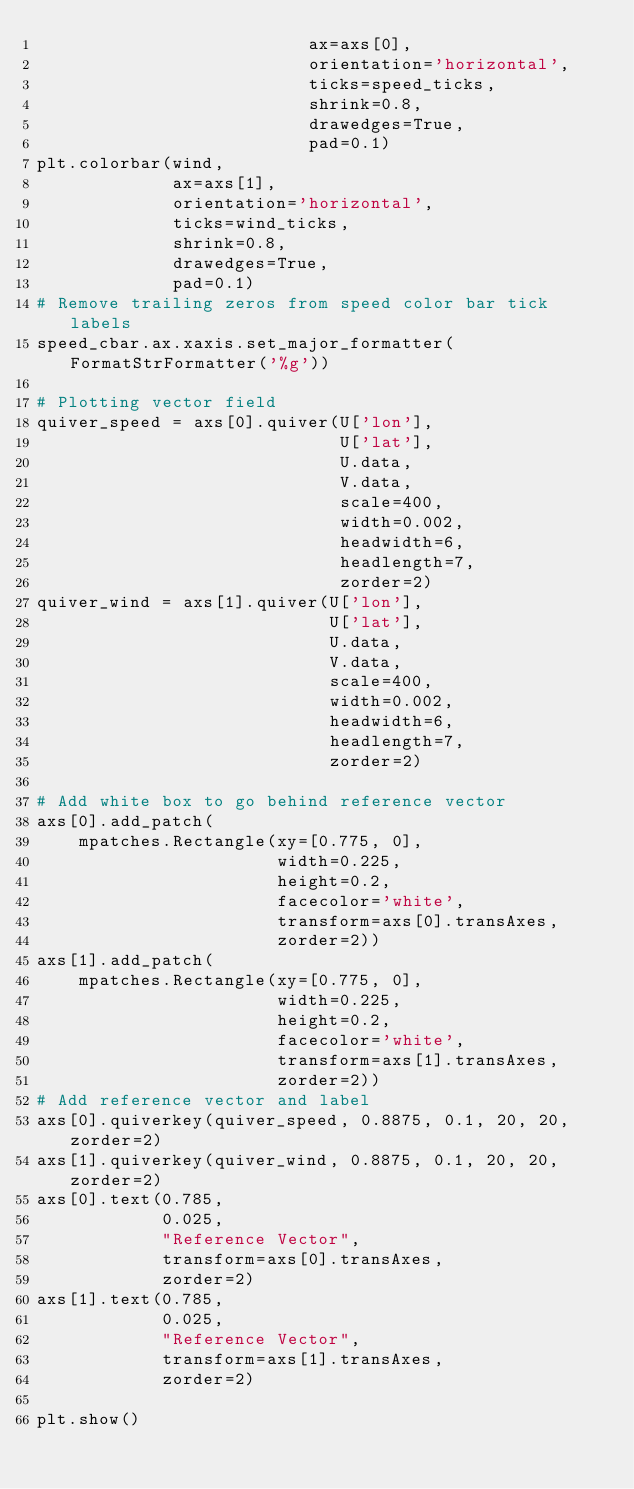<code> <loc_0><loc_0><loc_500><loc_500><_Python_>                          ax=axs[0],
                          orientation='horizontal',
                          ticks=speed_ticks,
                          shrink=0.8,
                          drawedges=True,
                          pad=0.1)
plt.colorbar(wind,
             ax=axs[1],
             orientation='horizontal',
             ticks=wind_ticks,
             shrink=0.8,
             drawedges=True,
             pad=0.1)
# Remove trailing zeros from speed color bar tick labels
speed_cbar.ax.xaxis.set_major_formatter(FormatStrFormatter('%g'))

# Plotting vector field
quiver_speed = axs[0].quiver(U['lon'],
                             U['lat'],
                             U.data,
                             V.data,
                             scale=400,
                             width=0.002,
                             headwidth=6,
                             headlength=7,
                             zorder=2)
quiver_wind = axs[1].quiver(U['lon'],
                            U['lat'],
                            U.data,
                            V.data,
                            scale=400,
                            width=0.002,
                            headwidth=6,
                            headlength=7,
                            zorder=2)

# Add white box to go behind reference vector
axs[0].add_patch(
    mpatches.Rectangle(xy=[0.775, 0],
                       width=0.225,
                       height=0.2,
                       facecolor='white',
                       transform=axs[0].transAxes,
                       zorder=2))
axs[1].add_patch(
    mpatches.Rectangle(xy=[0.775, 0],
                       width=0.225,
                       height=0.2,
                       facecolor='white',
                       transform=axs[1].transAxes,
                       zorder=2))
# Add reference vector and label
axs[0].quiverkey(quiver_speed, 0.8875, 0.1, 20, 20, zorder=2)
axs[1].quiverkey(quiver_wind, 0.8875, 0.1, 20, 20, zorder=2)
axs[0].text(0.785,
            0.025,
            "Reference Vector",
            transform=axs[0].transAxes,
            zorder=2)
axs[1].text(0.785,
            0.025,
            "Reference Vector",
            transform=axs[1].transAxes,
            zorder=2)

plt.show()
</code> 